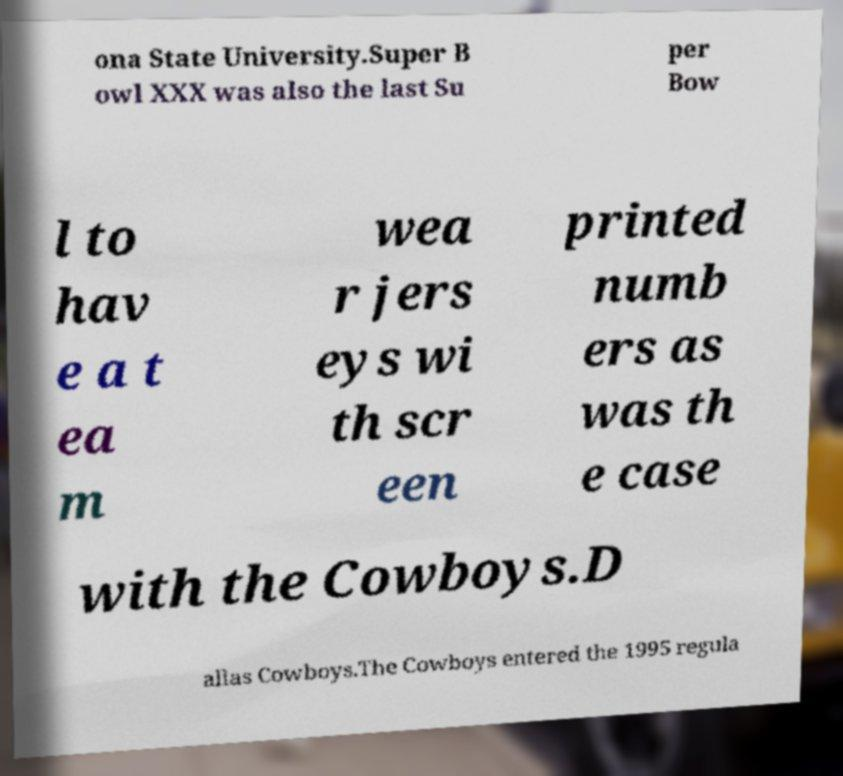Please read and relay the text visible in this image. What does it say? ona State University.Super B owl XXX was also the last Su per Bow l to hav e a t ea m wea r jers eys wi th scr een printed numb ers as was th e case with the Cowboys.D allas Cowboys.The Cowboys entered the 1995 regula 